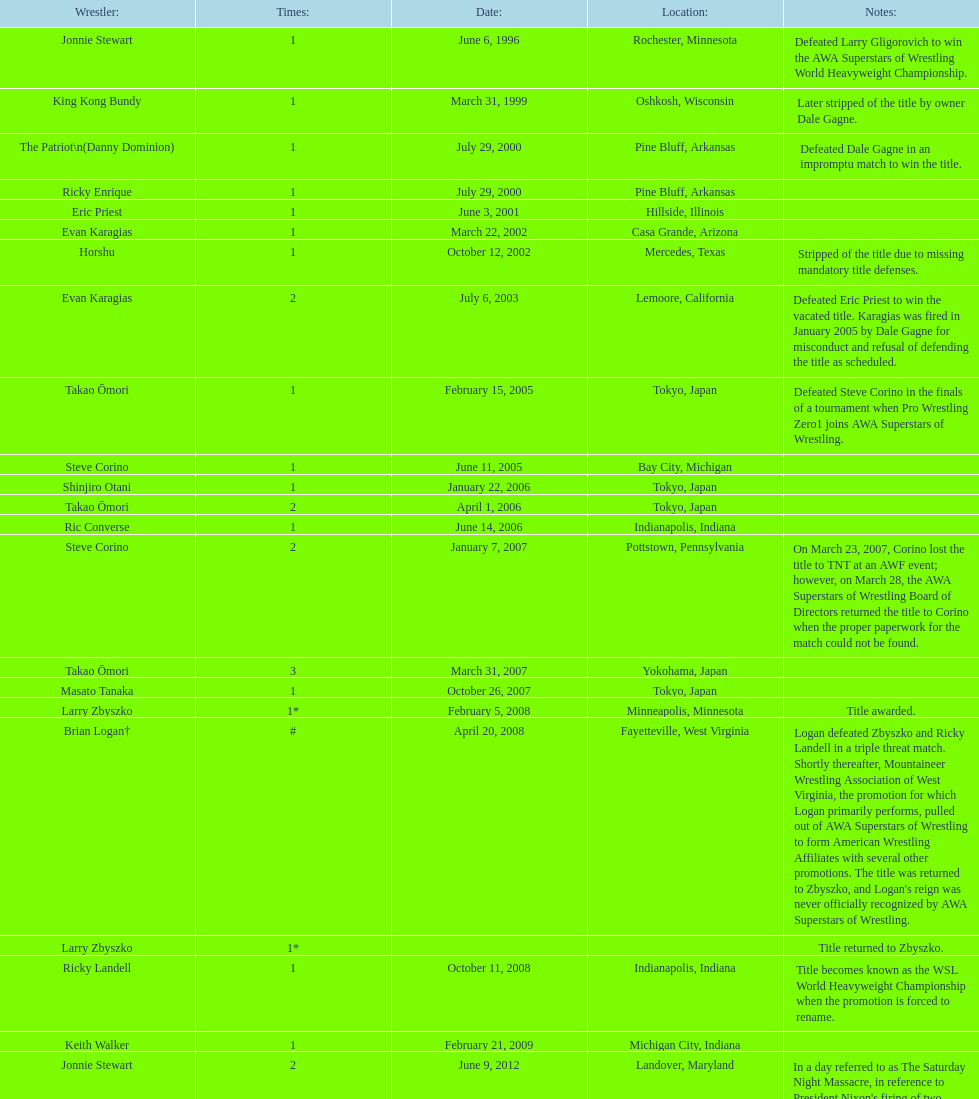Who is the only wsl title holder from texas? Horshu. 